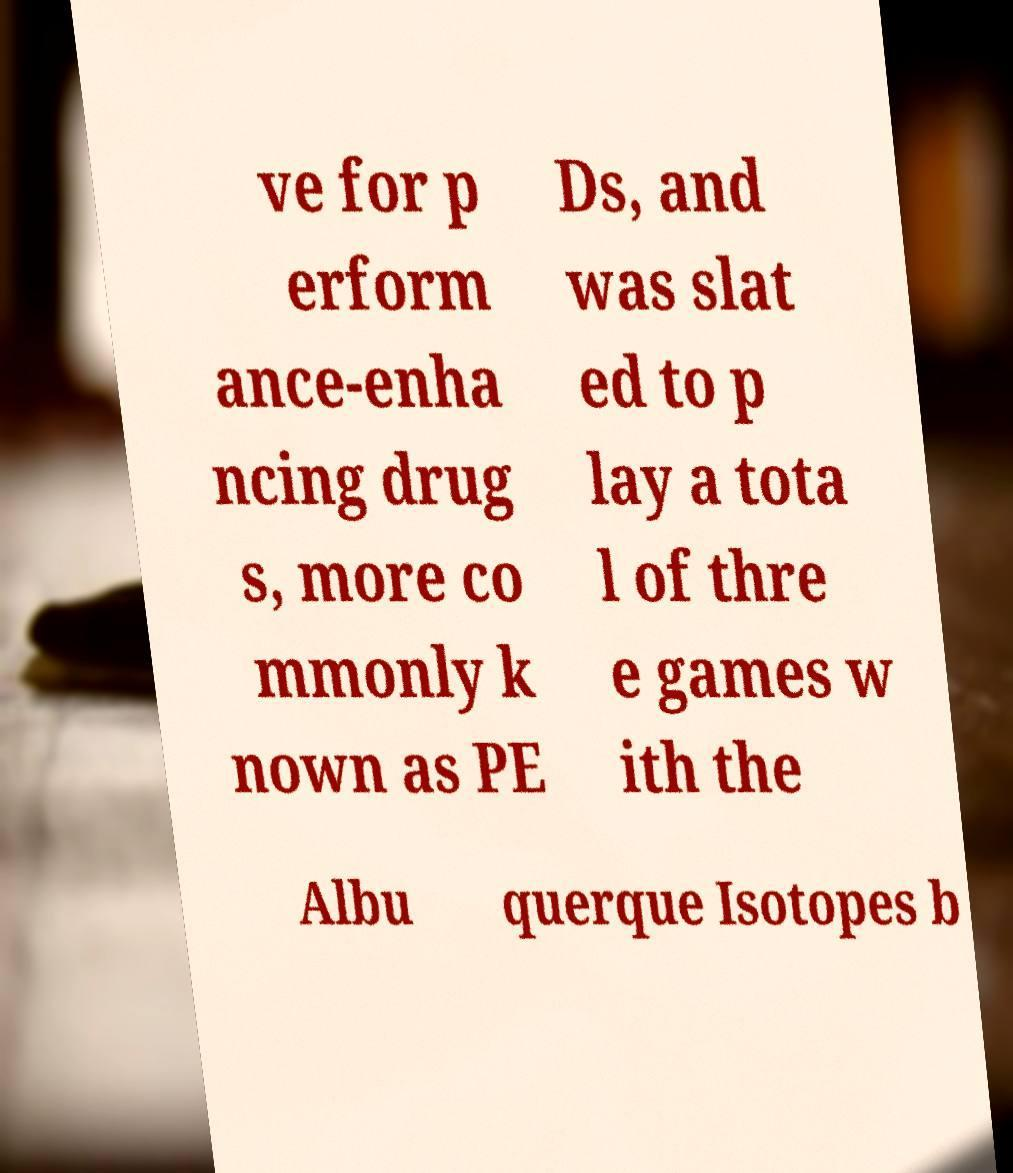I need the written content from this picture converted into text. Can you do that? ve for p erform ance-enha ncing drug s, more co mmonly k nown as PE Ds, and was slat ed to p lay a tota l of thre e games w ith the Albu querque Isotopes b 